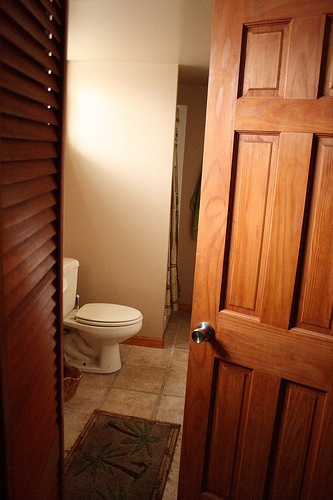Describe the objects in this image and their specific colors. I can see a toilet in black, maroon, tan, and gray tones in this image. 